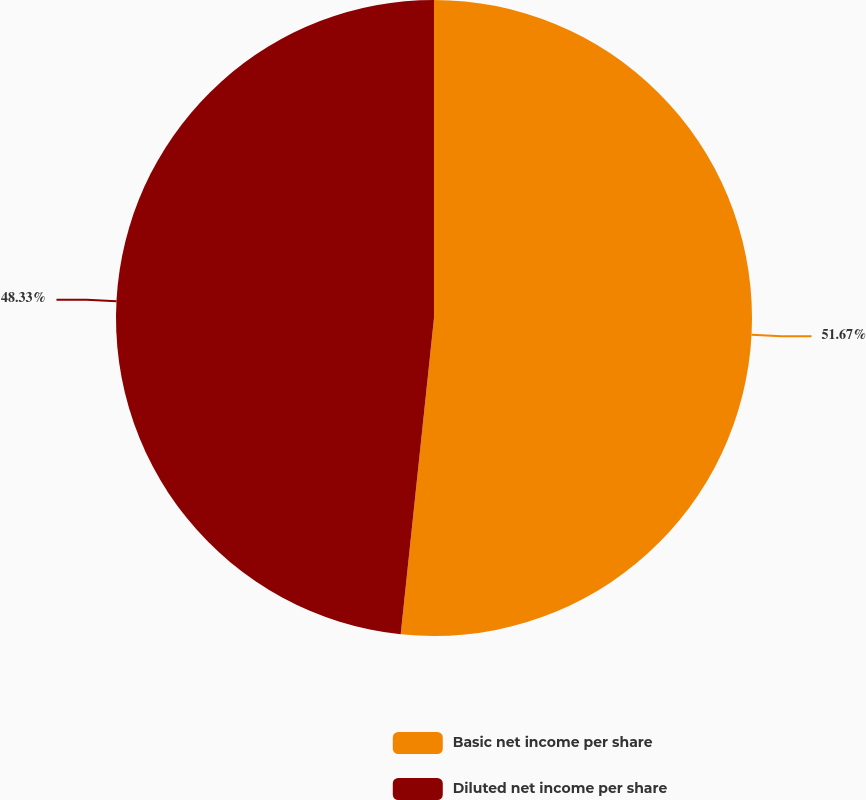<chart> <loc_0><loc_0><loc_500><loc_500><pie_chart><fcel>Basic net income per share<fcel>Diluted net income per share<nl><fcel>51.67%<fcel>48.33%<nl></chart> 